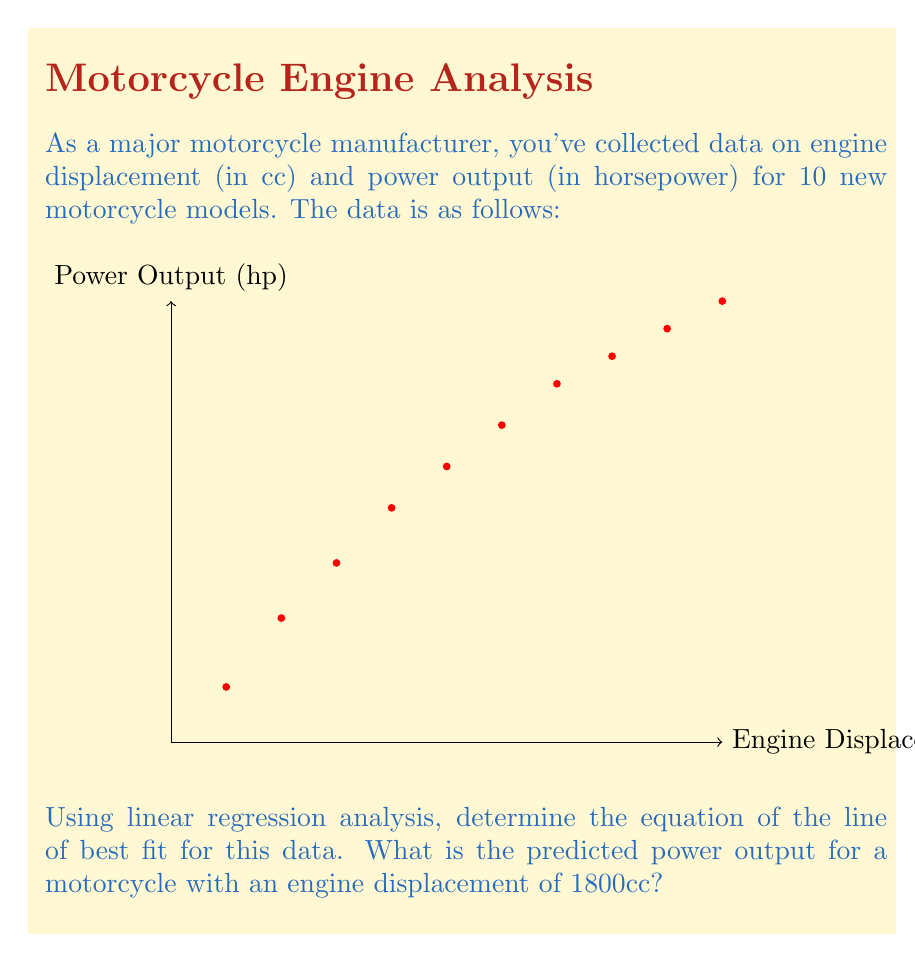Could you help me with this problem? To solve this problem, we'll use the least squares method for linear regression.

Step 1: Calculate the means of x (displacement) and y (power output).
$$\bar{x} = \frac{\sum x_i}{n} = 1375$$
$$\bar{y} = \frac{\sum y_i}{n} = 95$$

Step 2: Calculate the slope (m) of the regression line.
$$m = \frac{\sum (x_i - \bar{x})(y_i - \bar{y})}{\sum (x_i - \bar{x})^2}$$

Step 3: Calculate the y-intercept (b) of the regression line.
$$b = \bar{y} - m\bar{x}$$

Step 4: After calculations, we get:
$$m \approx 0.0596$$
$$b \approx 13.0556$$

Step 5: The equation of the line of best fit is:
$$y = 0.0596x + 13.0556$$

Step 6: To predict the power output for a 1800cc engine, substitute x = 1800 into the equation:
$$y = 0.0596(1800) + 13.0556 \approx 120.3356$$

Therefore, the predicted power output for a 1800cc engine is approximately 120.34 horsepower.
Answer: 120.34 hp 